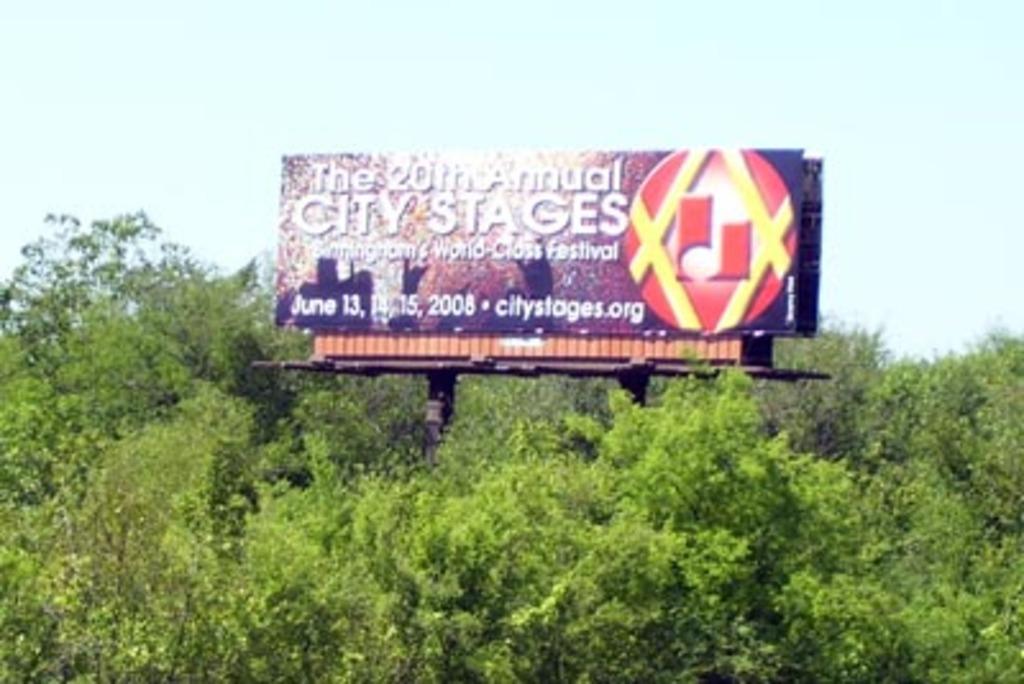What is being advertised?
Your answer should be compact. 20th annual city stages. 